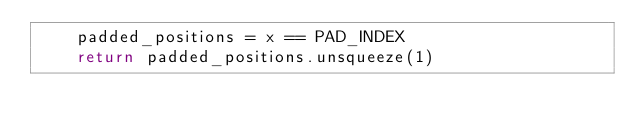Convert code to text. <code><loc_0><loc_0><loc_500><loc_500><_Python_>    padded_positions = x == PAD_INDEX
    return padded_positions.unsqueeze(1)</code> 